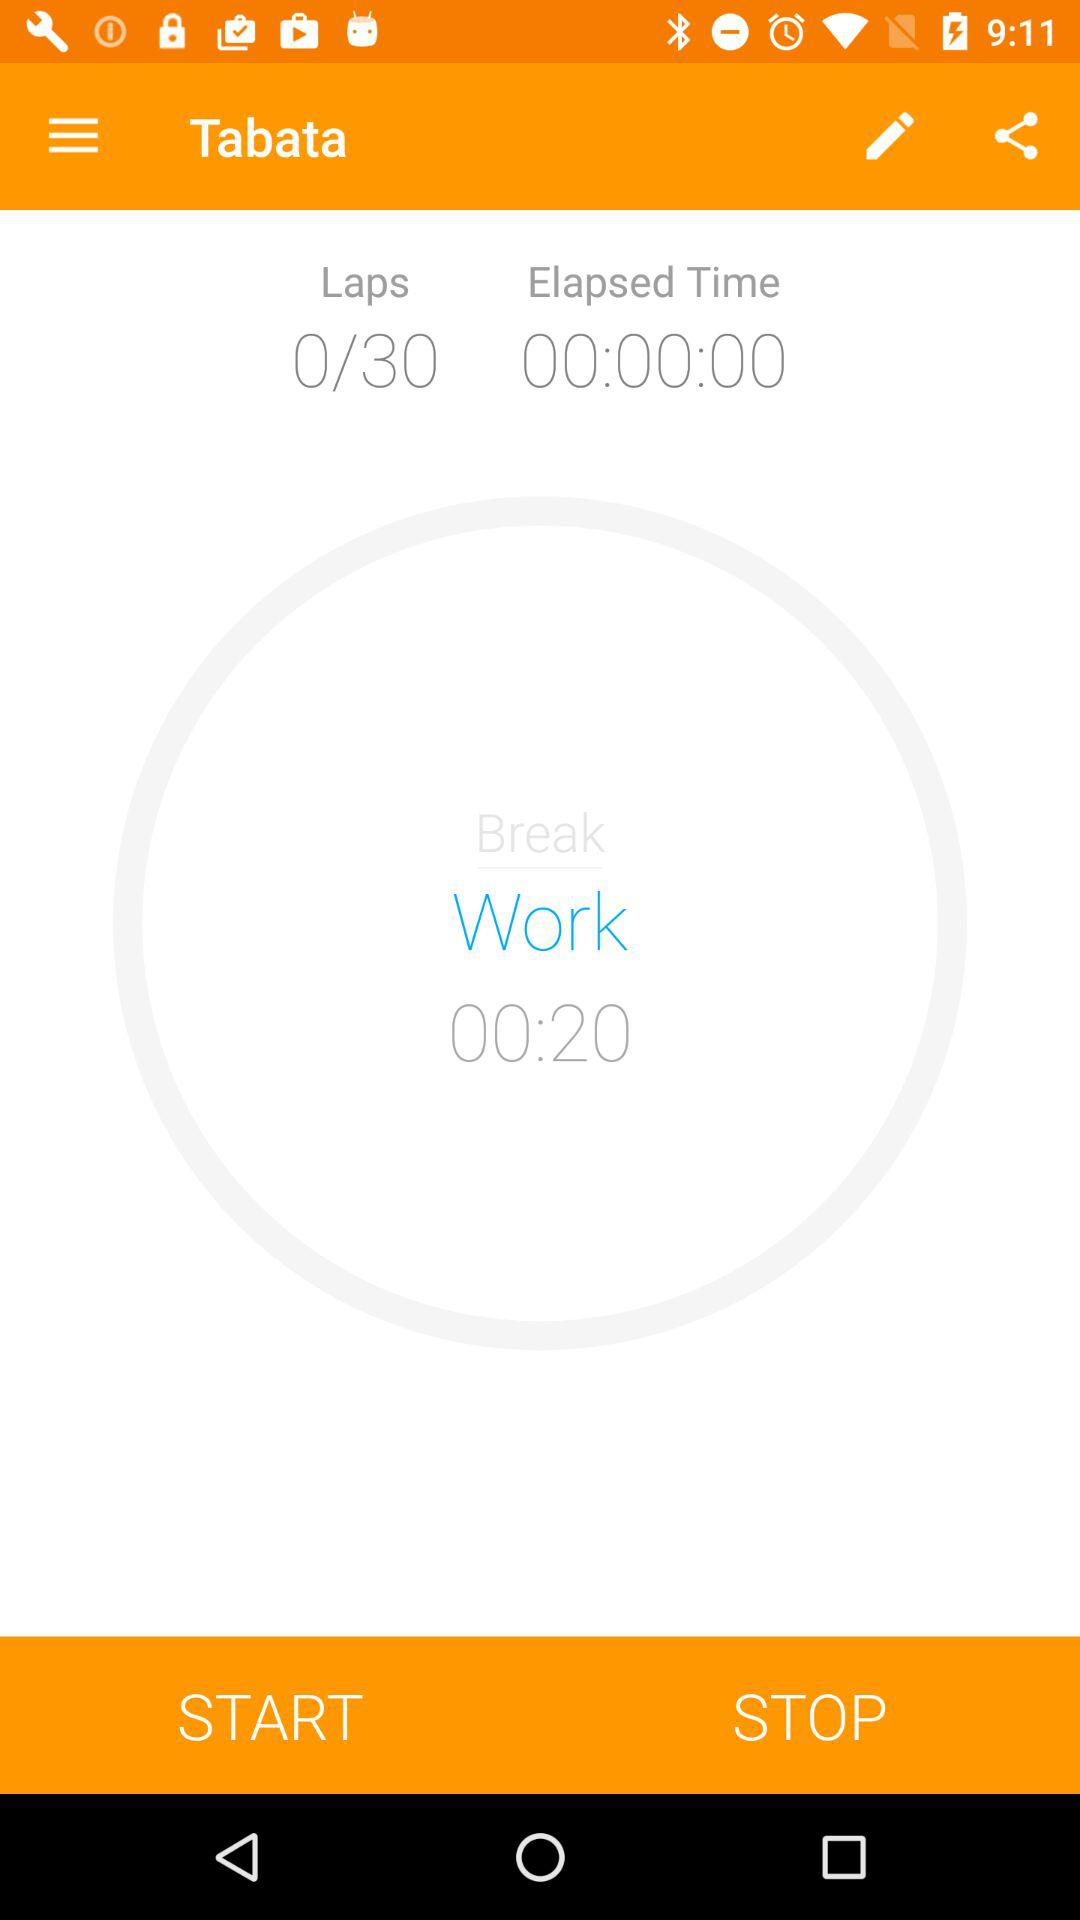What is the elapsed time? The elapsed time is 00:00:00. 